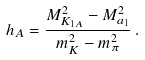<formula> <loc_0><loc_0><loc_500><loc_500>h _ { A } = \frac { M _ { K _ { 1 A } } ^ { 2 } - M _ { a _ { 1 } } ^ { 2 } } { m _ { K } ^ { 2 } - m _ { \pi } ^ { 2 } } \, .</formula> 